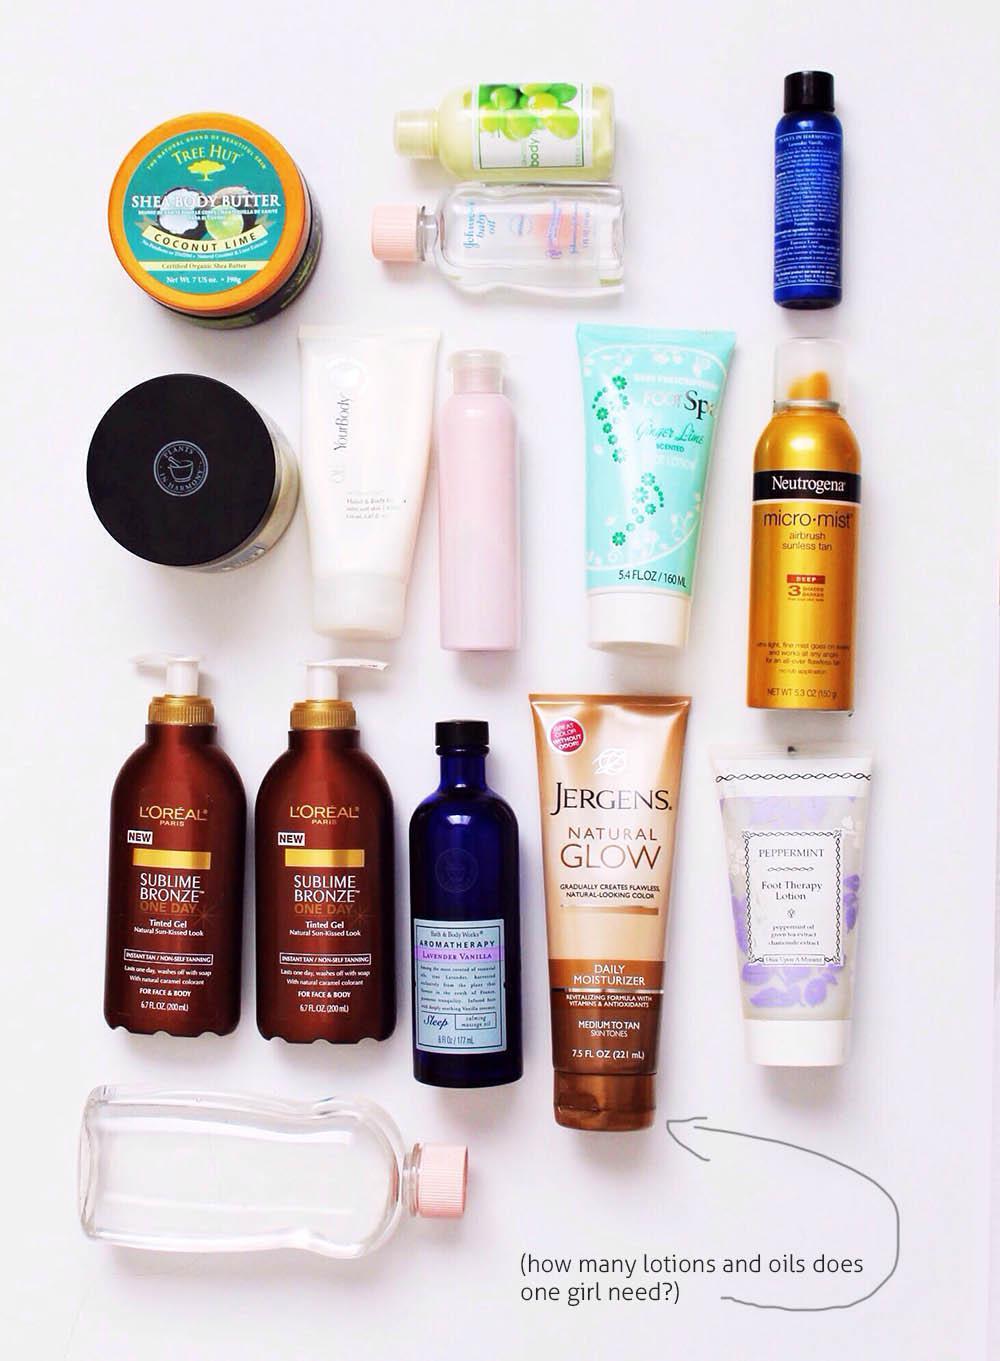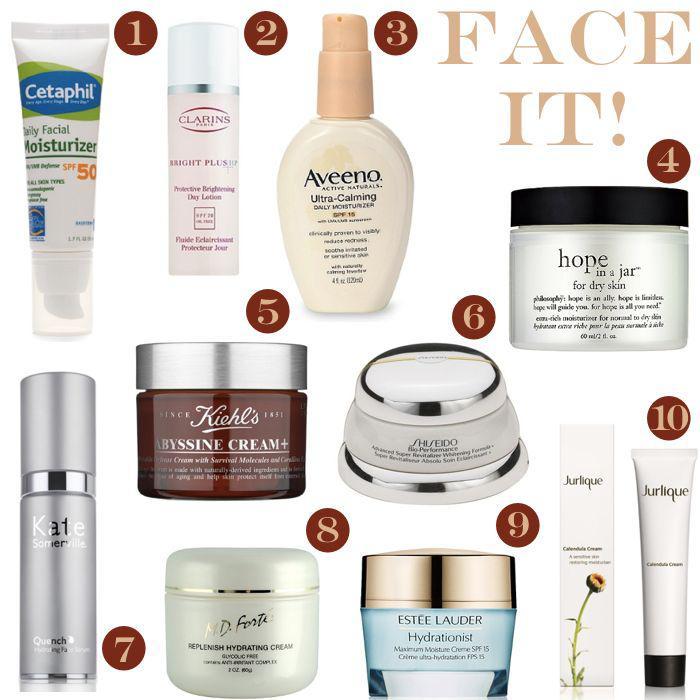The first image is the image on the left, the second image is the image on the right. Evaluate the accuracy of this statement regarding the images: "A grouping of skincare products includes at least one round shallow jar.". Is it true? Answer yes or no. Yes. 